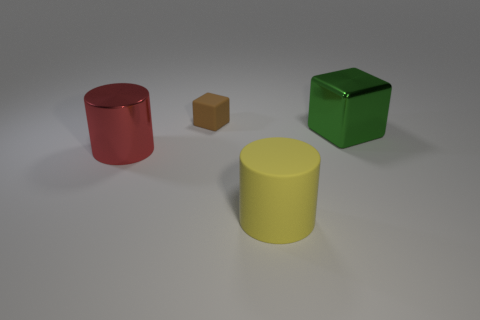Are there any other things that are the same size as the brown thing?
Make the answer very short. No. What number of other things are the same shape as the big green metal object?
Provide a short and direct response. 1. Does the big red thing to the left of the big metallic cube have the same shape as the small brown thing?
Provide a short and direct response. No. Are there any matte cylinders in front of the large red cylinder?
Provide a short and direct response. Yes. What number of big objects are green metallic cubes or cylinders?
Provide a short and direct response. 3. Does the red thing have the same material as the yellow cylinder?
Offer a very short reply. No. There is a yellow thing that is made of the same material as the tiny brown cube; what size is it?
Offer a very short reply. Large. What shape is the rubber thing on the left side of the large cylinder that is right of the block that is behind the big green block?
Ensure brevity in your answer.  Cube. The other green object that is the same shape as the tiny matte thing is what size?
Ensure brevity in your answer.  Large. There is a object that is behind the large red thing and in front of the small brown matte object; how big is it?
Offer a very short reply. Large. 